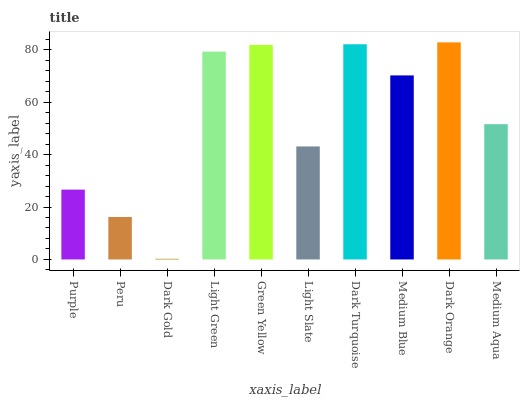Is Peru the minimum?
Answer yes or no. No. Is Peru the maximum?
Answer yes or no. No. Is Purple greater than Peru?
Answer yes or no. Yes. Is Peru less than Purple?
Answer yes or no. Yes. Is Peru greater than Purple?
Answer yes or no. No. Is Purple less than Peru?
Answer yes or no. No. Is Medium Blue the high median?
Answer yes or no. Yes. Is Medium Aqua the low median?
Answer yes or no. Yes. Is Medium Aqua the high median?
Answer yes or no. No. Is Dark Turquoise the low median?
Answer yes or no. No. 